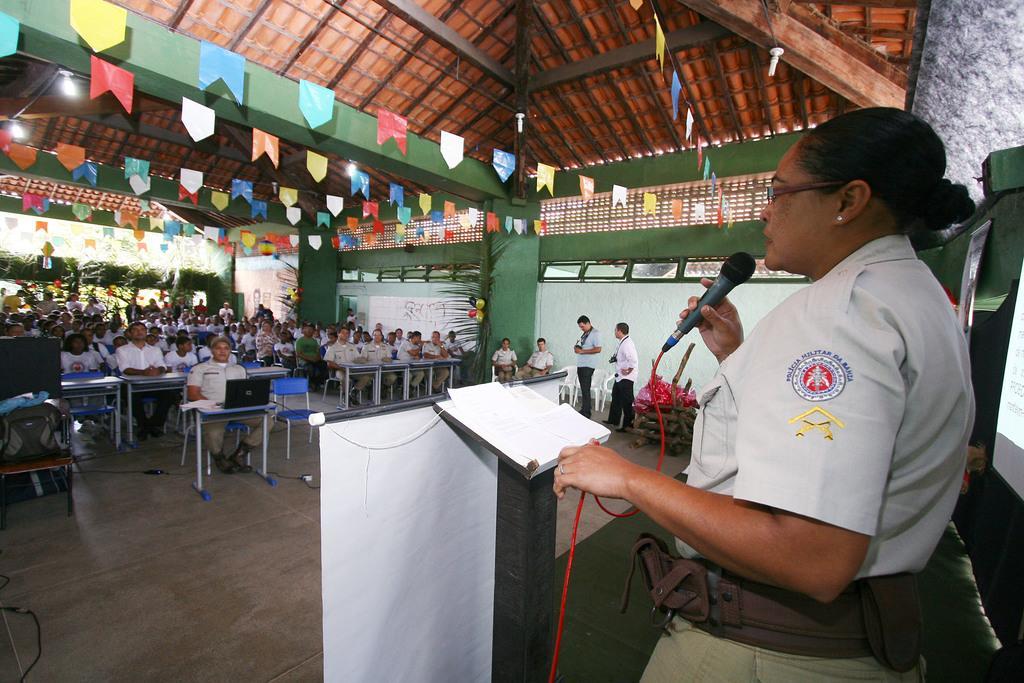Describe this image in one or two sentences. In this picture we can see a woman holding a mike in her hand and talking. This is a plate form. Here we can see papers. On the floor we can see people sitting on the chairs and these are tables. Here we can see two men standing with cameras. At the top we can see roof and paper flags. These are balloons. 